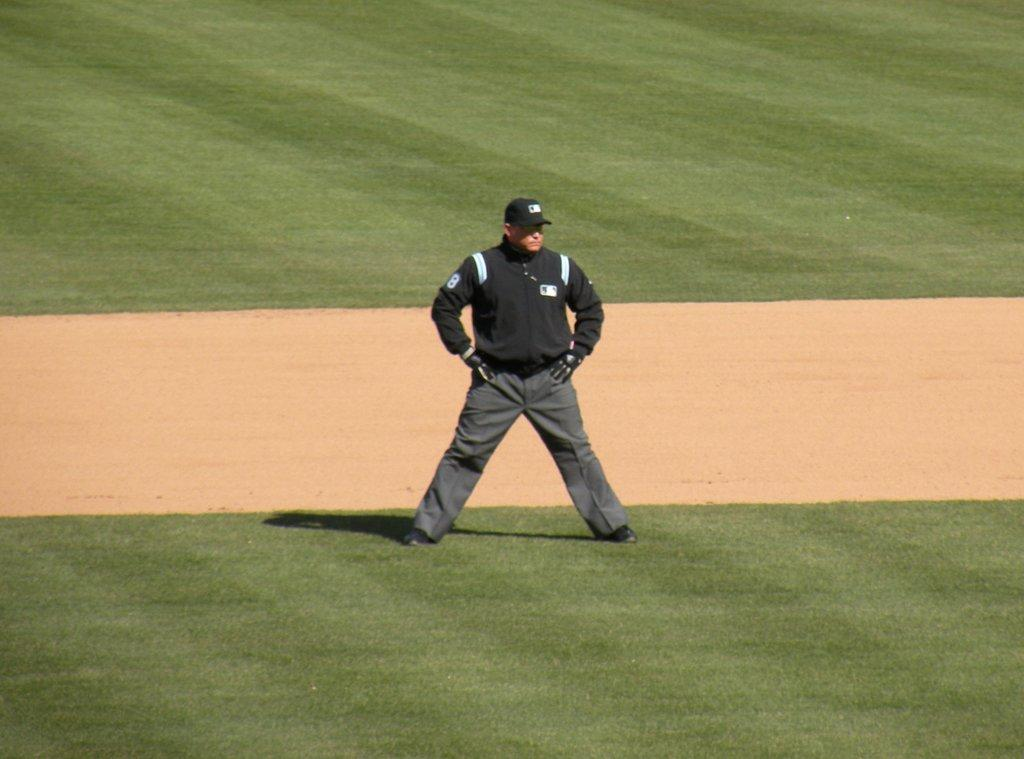Who or what is present in the image? There is a person in the image. What is the person wearing on their head? The person is wearing a cap. Where is the person standing? The person is standing on a grass field. What invention can be seen in the person's hand in the image? There is no invention visible in the person's hand in the image. How does the dust affect the person's visibility in the image? There is no dust present in the image, so it does not affect the person's visibility. 